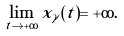<formula> <loc_0><loc_0><loc_500><loc_500>\lim _ { t \to + \infty } x _ { \gamma } ( t ) = + \infty .</formula> 